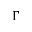<formula> <loc_0><loc_0><loc_500><loc_500>\Gamma</formula> 